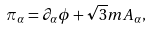Convert formula to latex. <formula><loc_0><loc_0><loc_500><loc_500>\pi _ { \alpha } = \partial _ { \alpha } \phi + \sqrt { 3 } m A _ { \alpha } ,</formula> 